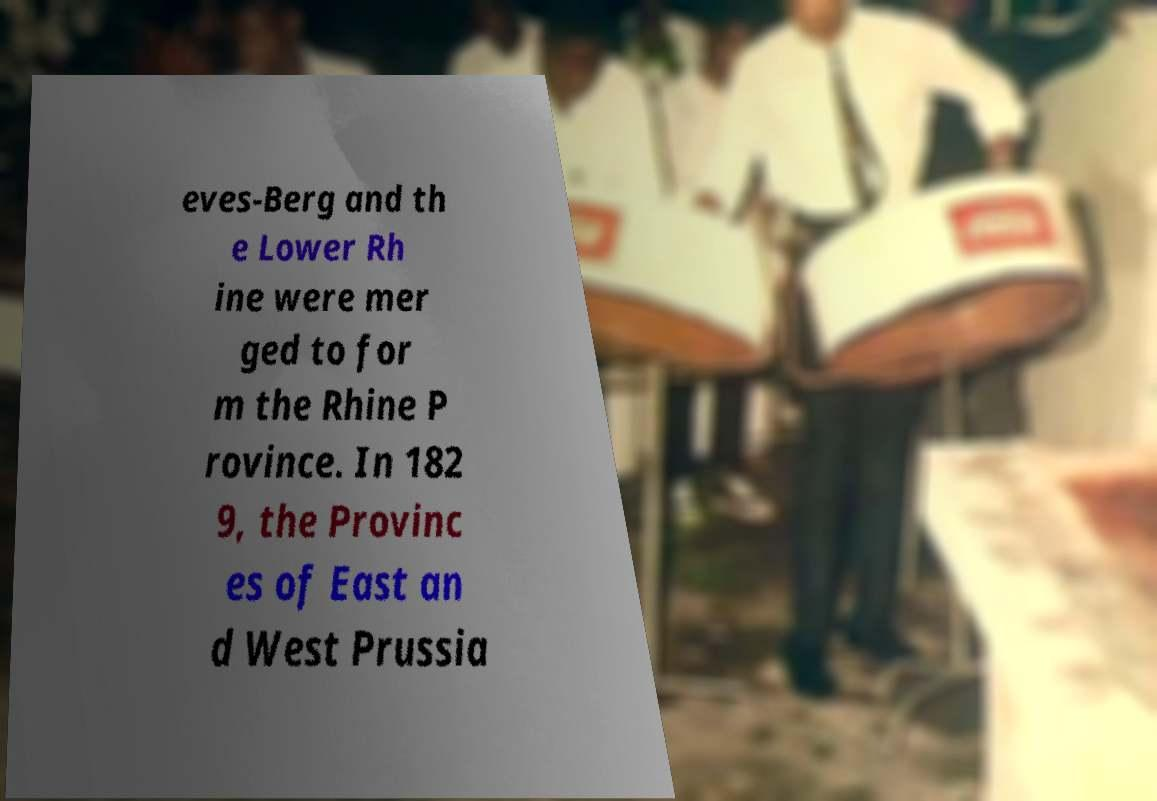For documentation purposes, I need the text within this image transcribed. Could you provide that? eves-Berg and th e Lower Rh ine were mer ged to for m the Rhine P rovince. In 182 9, the Provinc es of East an d West Prussia 